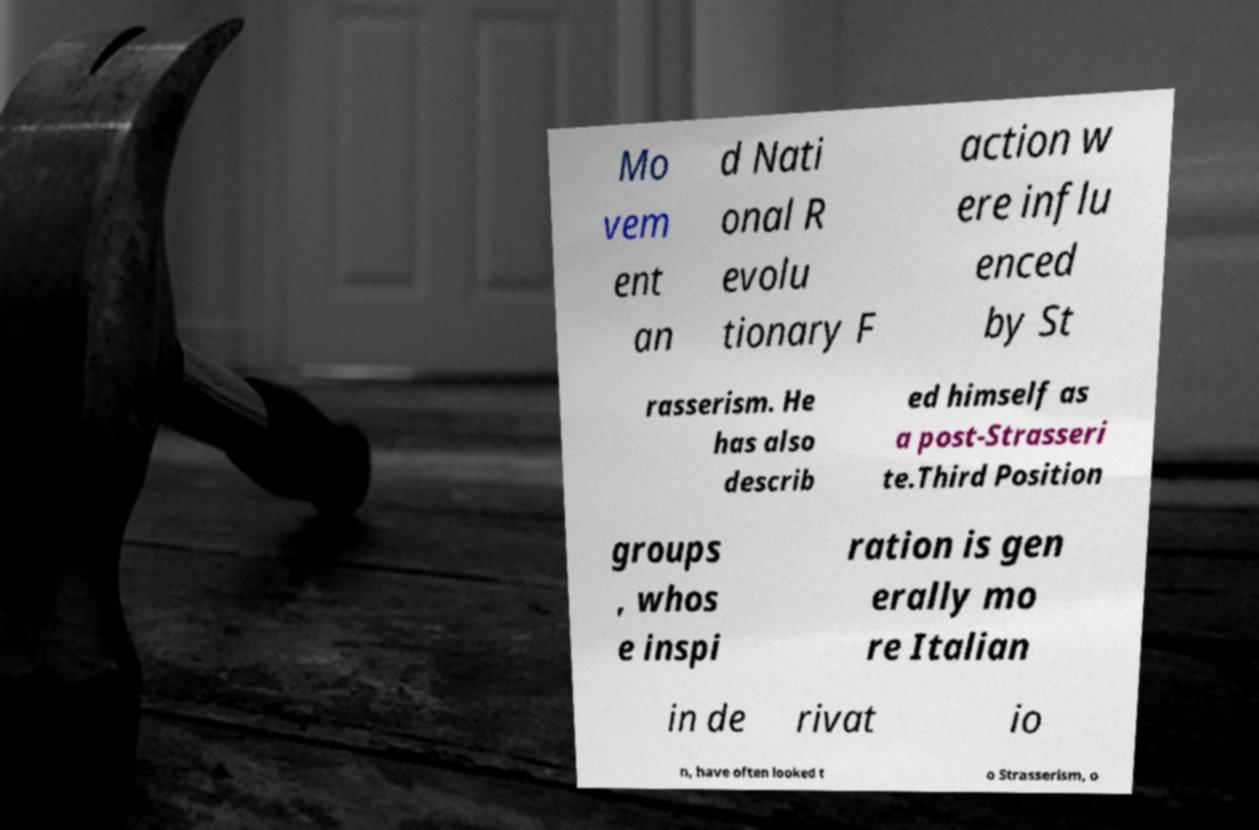What messages or text are displayed in this image? I need them in a readable, typed format. Mo vem ent an d Nati onal R evolu tionary F action w ere influ enced by St rasserism. He has also describ ed himself as a post-Strasseri te.Third Position groups , whos e inspi ration is gen erally mo re Italian in de rivat io n, have often looked t o Strasserism, o 